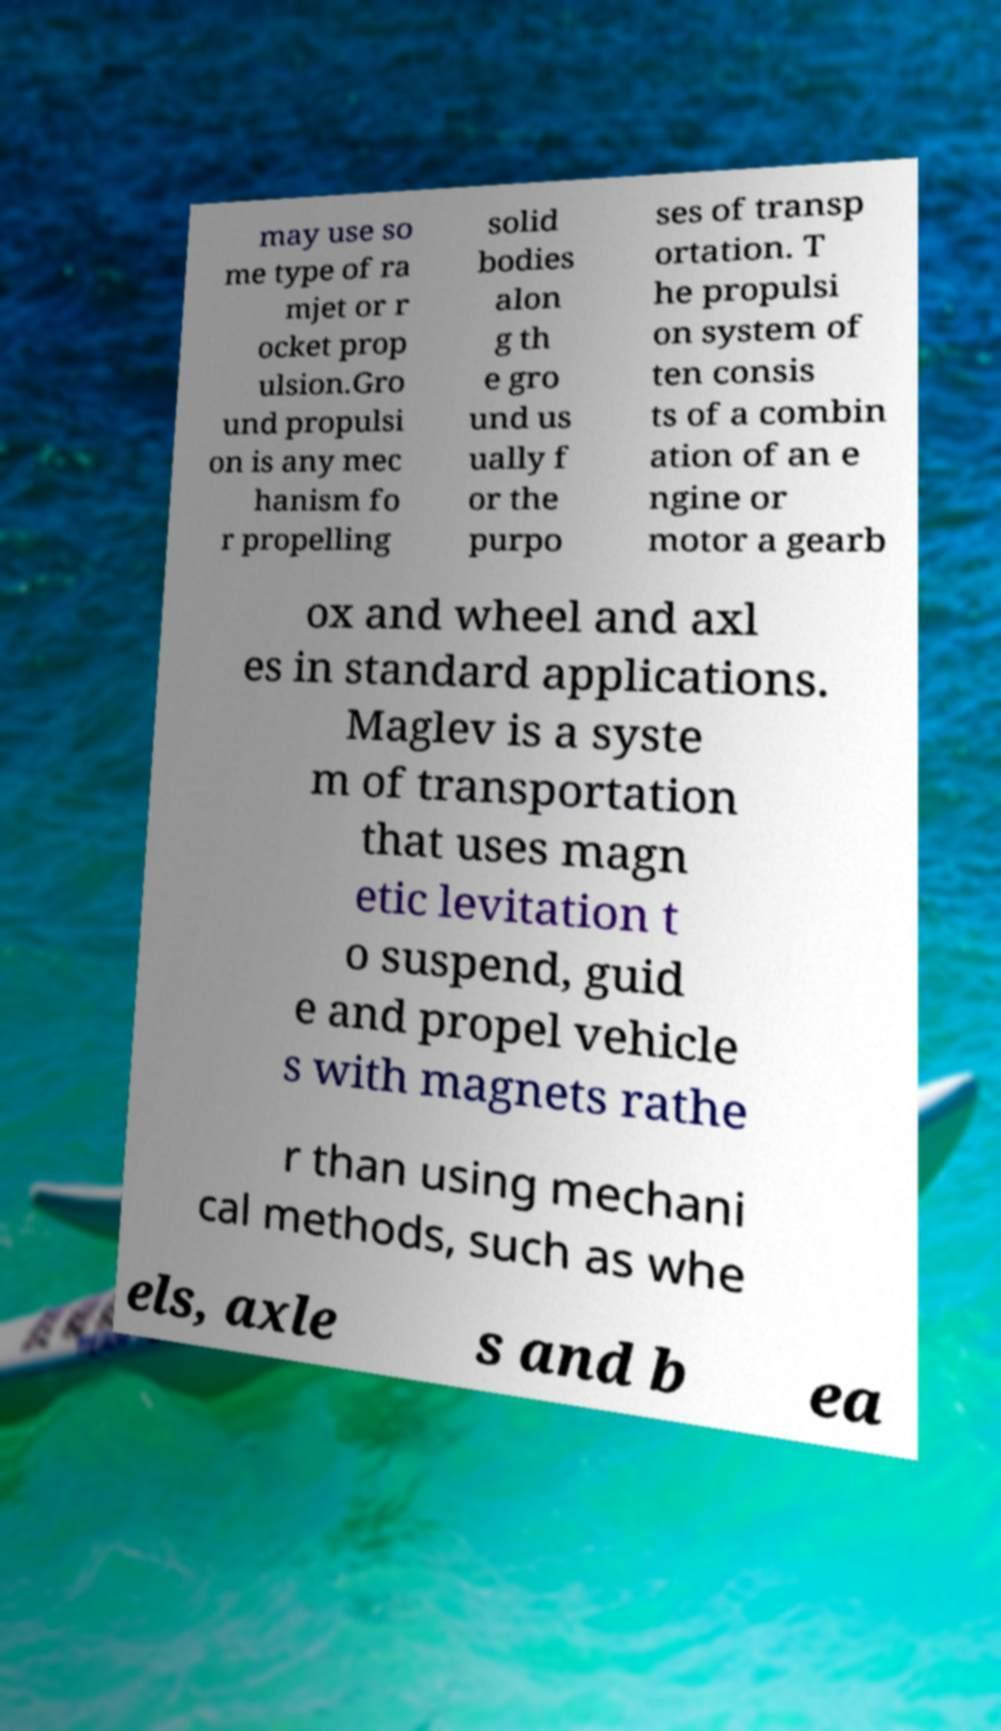Please identify and transcribe the text found in this image. may use so me type of ra mjet or r ocket prop ulsion.Gro und propulsi on is any mec hanism fo r propelling solid bodies alon g th e gro und us ually f or the purpo ses of transp ortation. T he propulsi on system of ten consis ts of a combin ation of an e ngine or motor a gearb ox and wheel and axl es in standard applications. Maglev is a syste m of transportation that uses magn etic levitation t o suspend, guid e and propel vehicle s with magnets rathe r than using mechani cal methods, such as whe els, axle s and b ea 